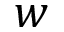Convert formula to latex. <formula><loc_0><loc_0><loc_500><loc_500>w</formula> 